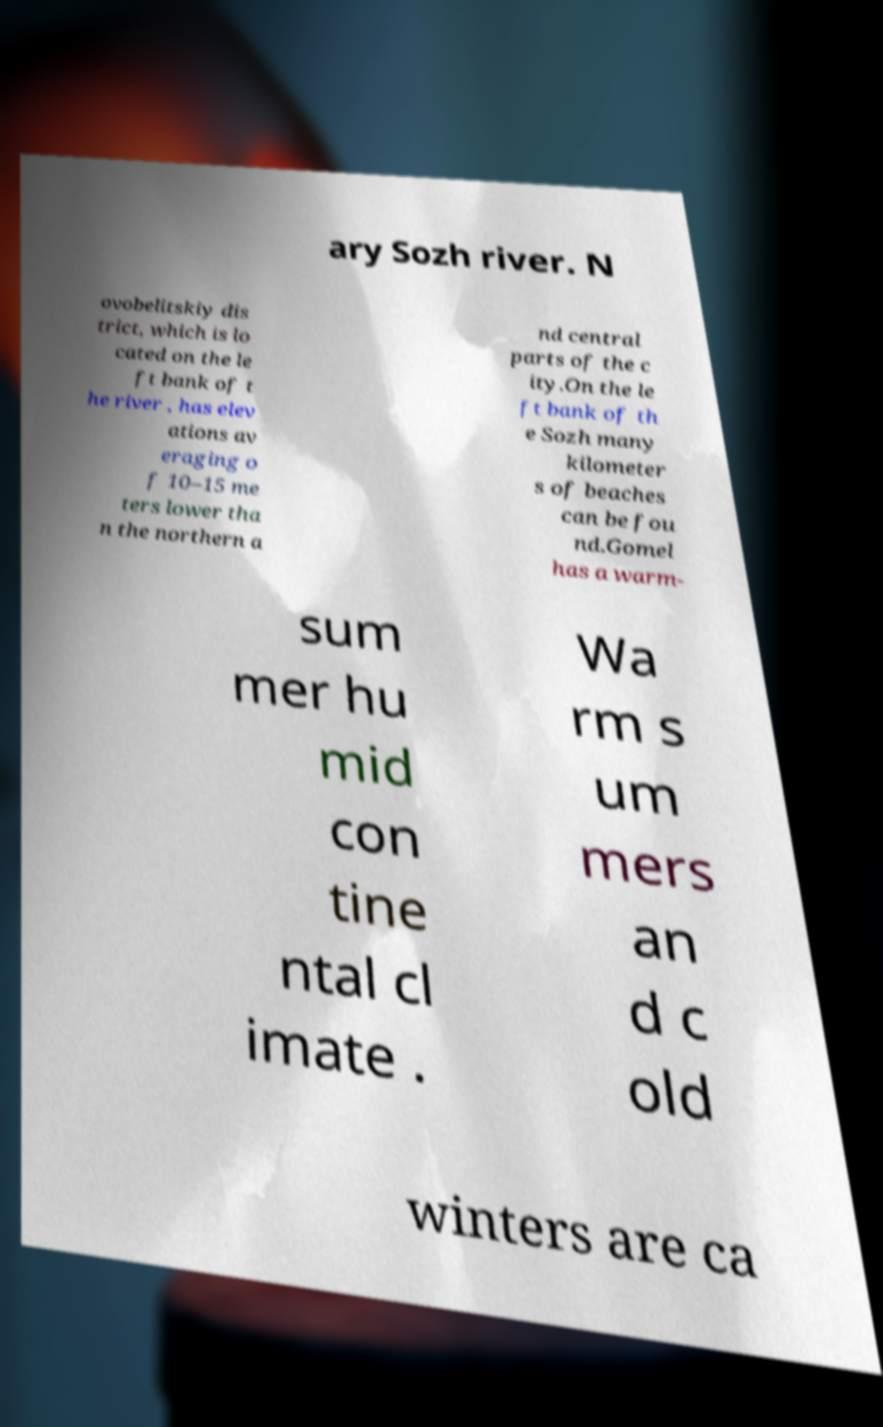What messages or text are displayed in this image? I need them in a readable, typed format. ary Sozh river. N ovobelitskiy dis trict, which is lo cated on the le ft bank of t he river , has elev ations av eraging o f 10–15 me ters lower tha n the northern a nd central parts of the c ity.On the le ft bank of th e Sozh many kilometer s of beaches can be fou nd.Gomel has a warm- sum mer hu mid con tine ntal cl imate . Wa rm s um mers an d c old winters are ca 